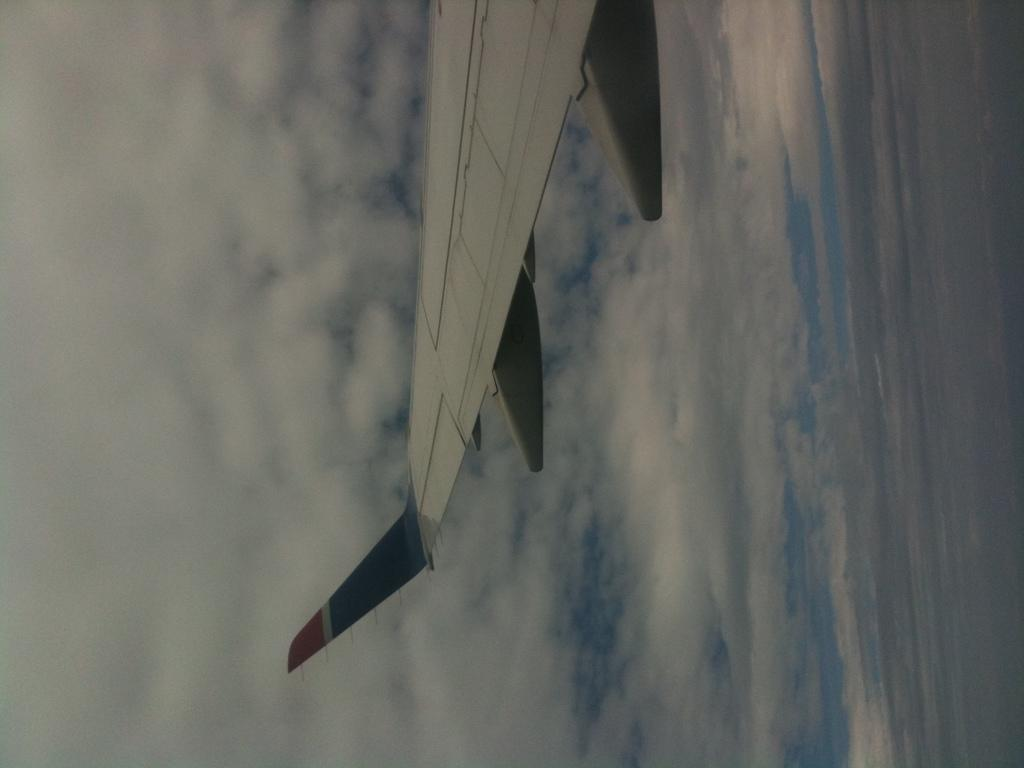What part of an airplane can be seen in the image? The wing part of an airplane is visible in the image. What can be seen in the sky in the image? There are clouds visible in the sky. What type of zipper can be seen on the wing of the airplane in the image? There is no zipper present on the wing of the airplane in the image. 